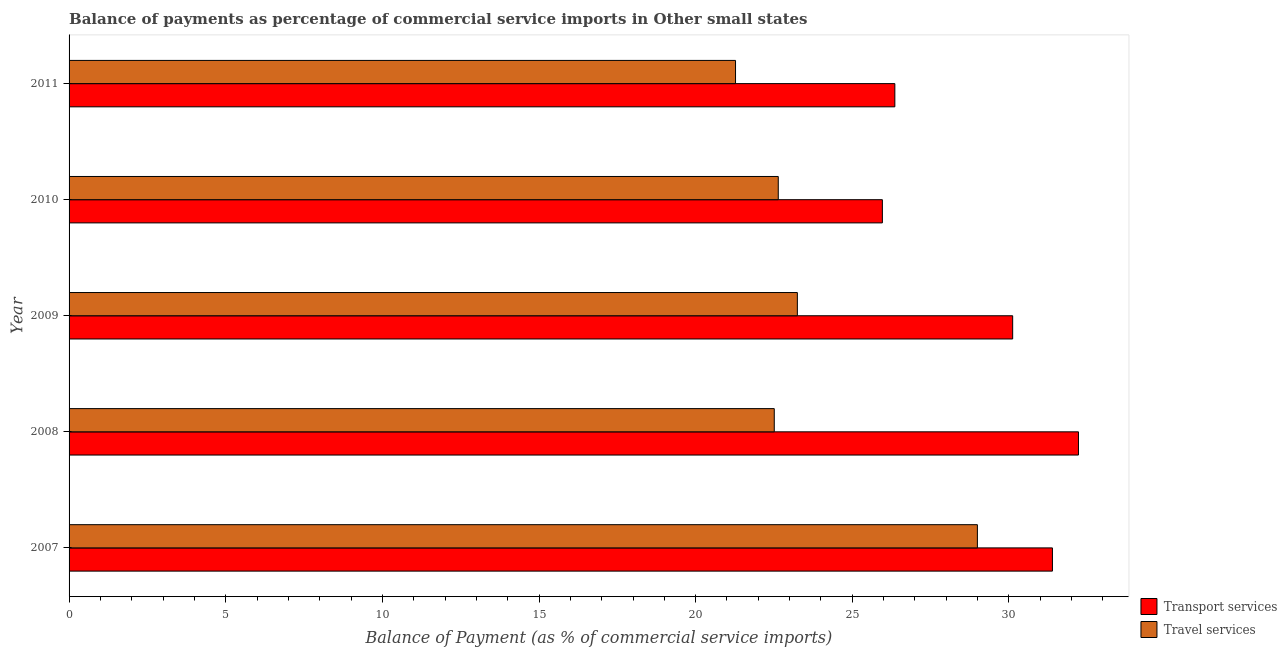How many different coloured bars are there?
Your response must be concise. 2. Are the number of bars on each tick of the Y-axis equal?
Ensure brevity in your answer.  Yes. How many bars are there on the 1st tick from the top?
Offer a terse response. 2. How many bars are there on the 5th tick from the bottom?
Offer a very short reply. 2. What is the balance of payments of travel services in 2008?
Provide a short and direct response. 22.51. Across all years, what is the maximum balance of payments of travel services?
Provide a short and direct response. 28.99. Across all years, what is the minimum balance of payments of transport services?
Keep it short and to the point. 25.96. In which year was the balance of payments of transport services minimum?
Your answer should be compact. 2010. What is the total balance of payments of travel services in the graph?
Offer a terse response. 118.66. What is the difference between the balance of payments of transport services in 2007 and that in 2010?
Offer a very short reply. 5.43. What is the difference between the balance of payments of transport services in 2011 and the balance of payments of travel services in 2010?
Provide a succinct answer. 3.72. What is the average balance of payments of travel services per year?
Keep it short and to the point. 23.73. In the year 2008, what is the difference between the balance of payments of transport services and balance of payments of travel services?
Your answer should be very brief. 9.71. In how many years, is the balance of payments of travel services greater than 9 %?
Keep it short and to the point. 5. What is the ratio of the balance of payments of transport services in 2008 to that in 2009?
Make the answer very short. 1.07. Is the balance of payments of transport services in 2007 less than that in 2010?
Provide a succinct answer. No. What is the difference between the highest and the second highest balance of payments of travel services?
Give a very brief answer. 5.75. What is the difference between the highest and the lowest balance of payments of travel services?
Offer a terse response. 7.72. In how many years, is the balance of payments of transport services greater than the average balance of payments of transport services taken over all years?
Offer a terse response. 3. What does the 1st bar from the top in 2008 represents?
Make the answer very short. Travel services. What does the 2nd bar from the bottom in 2011 represents?
Your answer should be very brief. Travel services. How many years are there in the graph?
Your answer should be very brief. 5. Are the values on the major ticks of X-axis written in scientific E-notation?
Offer a terse response. No. Does the graph contain any zero values?
Offer a terse response. No. How many legend labels are there?
Offer a terse response. 2. How are the legend labels stacked?
Your answer should be very brief. Vertical. What is the title of the graph?
Your response must be concise. Balance of payments as percentage of commercial service imports in Other small states. What is the label or title of the X-axis?
Make the answer very short. Balance of Payment (as % of commercial service imports). What is the label or title of the Y-axis?
Provide a short and direct response. Year. What is the Balance of Payment (as % of commercial service imports) in Transport services in 2007?
Offer a terse response. 31.39. What is the Balance of Payment (as % of commercial service imports) in Travel services in 2007?
Provide a short and direct response. 28.99. What is the Balance of Payment (as % of commercial service imports) in Transport services in 2008?
Ensure brevity in your answer.  32.22. What is the Balance of Payment (as % of commercial service imports) in Travel services in 2008?
Ensure brevity in your answer.  22.51. What is the Balance of Payment (as % of commercial service imports) of Transport services in 2009?
Ensure brevity in your answer.  30.12. What is the Balance of Payment (as % of commercial service imports) in Travel services in 2009?
Your answer should be compact. 23.25. What is the Balance of Payment (as % of commercial service imports) in Transport services in 2010?
Keep it short and to the point. 25.96. What is the Balance of Payment (as % of commercial service imports) of Travel services in 2010?
Provide a succinct answer. 22.64. What is the Balance of Payment (as % of commercial service imports) in Transport services in 2011?
Offer a very short reply. 26.36. What is the Balance of Payment (as % of commercial service imports) in Travel services in 2011?
Your answer should be very brief. 21.27. Across all years, what is the maximum Balance of Payment (as % of commercial service imports) of Transport services?
Offer a terse response. 32.22. Across all years, what is the maximum Balance of Payment (as % of commercial service imports) in Travel services?
Offer a very short reply. 28.99. Across all years, what is the minimum Balance of Payment (as % of commercial service imports) of Transport services?
Offer a terse response. 25.96. Across all years, what is the minimum Balance of Payment (as % of commercial service imports) of Travel services?
Keep it short and to the point. 21.27. What is the total Balance of Payment (as % of commercial service imports) of Transport services in the graph?
Make the answer very short. 146.05. What is the total Balance of Payment (as % of commercial service imports) in Travel services in the graph?
Provide a succinct answer. 118.66. What is the difference between the Balance of Payment (as % of commercial service imports) of Transport services in 2007 and that in 2008?
Provide a succinct answer. -0.83. What is the difference between the Balance of Payment (as % of commercial service imports) in Travel services in 2007 and that in 2008?
Your answer should be compact. 6.48. What is the difference between the Balance of Payment (as % of commercial service imports) in Transport services in 2007 and that in 2009?
Your response must be concise. 1.27. What is the difference between the Balance of Payment (as % of commercial service imports) of Travel services in 2007 and that in 2009?
Keep it short and to the point. 5.75. What is the difference between the Balance of Payment (as % of commercial service imports) of Transport services in 2007 and that in 2010?
Your answer should be compact. 5.43. What is the difference between the Balance of Payment (as % of commercial service imports) of Travel services in 2007 and that in 2010?
Your response must be concise. 6.36. What is the difference between the Balance of Payment (as % of commercial service imports) in Transport services in 2007 and that in 2011?
Ensure brevity in your answer.  5.03. What is the difference between the Balance of Payment (as % of commercial service imports) of Travel services in 2007 and that in 2011?
Keep it short and to the point. 7.72. What is the difference between the Balance of Payment (as % of commercial service imports) of Transport services in 2008 and that in 2009?
Your answer should be compact. 2.1. What is the difference between the Balance of Payment (as % of commercial service imports) of Travel services in 2008 and that in 2009?
Provide a short and direct response. -0.74. What is the difference between the Balance of Payment (as % of commercial service imports) in Transport services in 2008 and that in 2010?
Offer a terse response. 6.26. What is the difference between the Balance of Payment (as % of commercial service imports) of Travel services in 2008 and that in 2010?
Offer a terse response. -0.13. What is the difference between the Balance of Payment (as % of commercial service imports) of Transport services in 2008 and that in 2011?
Keep it short and to the point. 5.86. What is the difference between the Balance of Payment (as % of commercial service imports) of Travel services in 2008 and that in 2011?
Make the answer very short. 1.24. What is the difference between the Balance of Payment (as % of commercial service imports) in Transport services in 2009 and that in 2010?
Offer a terse response. 4.16. What is the difference between the Balance of Payment (as % of commercial service imports) in Travel services in 2009 and that in 2010?
Provide a short and direct response. 0.61. What is the difference between the Balance of Payment (as % of commercial service imports) in Transport services in 2009 and that in 2011?
Your answer should be compact. 3.76. What is the difference between the Balance of Payment (as % of commercial service imports) of Travel services in 2009 and that in 2011?
Give a very brief answer. 1.97. What is the difference between the Balance of Payment (as % of commercial service imports) of Transport services in 2010 and that in 2011?
Offer a very short reply. -0.4. What is the difference between the Balance of Payment (as % of commercial service imports) of Travel services in 2010 and that in 2011?
Your answer should be compact. 1.36. What is the difference between the Balance of Payment (as % of commercial service imports) in Transport services in 2007 and the Balance of Payment (as % of commercial service imports) in Travel services in 2008?
Provide a succinct answer. 8.88. What is the difference between the Balance of Payment (as % of commercial service imports) of Transport services in 2007 and the Balance of Payment (as % of commercial service imports) of Travel services in 2009?
Your response must be concise. 8.14. What is the difference between the Balance of Payment (as % of commercial service imports) in Transport services in 2007 and the Balance of Payment (as % of commercial service imports) in Travel services in 2010?
Offer a terse response. 8.75. What is the difference between the Balance of Payment (as % of commercial service imports) in Transport services in 2007 and the Balance of Payment (as % of commercial service imports) in Travel services in 2011?
Offer a terse response. 10.12. What is the difference between the Balance of Payment (as % of commercial service imports) in Transport services in 2008 and the Balance of Payment (as % of commercial service imports) in Travel services in 2009?
Offer a very short reply. 8.97. What is the difference between the Balance of Payment (as % of commercial service imports) in Transport services in 2008 and the Balance of Payment (as % of commercial service imports) in Travel services in 2010?
Ensure brevity in your answer.  9.58. What is the difference between the Balance of Payment (as % of commercial service imports) in Transport services in 2008 and the Balance of Payment (as % of commercial service imports) in Travel services in 2011?
Keep it short and to the point. 10.95. What is the difference between the Balance of Payment (as % of commercial service imports) of Transport services in 2009 and the Balance of Payment (as % of commercial service imports) of Travel services in 2010?
Your response must be concise. 7.48. What is the difference between the Balance of Payment (as % of commercial service imports) in Transport services in 2009 and the Balance of Payment (as % of commercial service imports) in Travel services in 2011?
Ensure brevity in your answer.  8.85. What is the difference between the Balance of Payment (as % of commercial service imports) in Transport services in 2010 and the Balance of Payment (as % of commercial service imports) in Travel services in 2011?
Your answer should be very brief. 4.69. What is the average Balance of Payment (as % of commercial service imports) in Transport services per year?
Provide a succinct answer. 29.21. What is the average Balance of Payment (as % of commercial service imports) of Travel services per year?
Provide a succinct answer. 23.73. In the year 2007, what is the difference between the Balance of Payment (as % of commercial service imports) in Transport services and Balance of Payment (as % of commercial service imports) in Travel services?
Provide a succinct answer. 2.4. In the year 2008, what is the difference between the Balance of Payment (as % of commercial service imports) of Transport services and Balance of Payment (as % of commercial service imports) of Travel services?
Provide a short and direct response. 9.71. In the year 2009, what is the difference between the Balance of Payment (as % of commercial service imports) of Transport services and Balance of Payment (as % of commercial service imports) of Travel services?
Your answer should be compact. 6.87. In the year 2010, what is the difference between the Balance of Payment (as % of commercial service imports) of Transport services and Balance of Payment (as % of commercial service imports) of Travel services?
Offer a very short reply. 3.32. In the year 2011, what is the difference between the Balance of Payment (as % of commercial service imports) of Transport services and Balance of Payment (as % of commercial service imports) of Travel services?
Provide a short and direct response. 5.09. What is the ratio of the Balance of Payment (as % of commercial service imports) of Transport services in 2007 to that in 2008?
Give a very brief answer. 0.97. What is the ratio of the Balance of Payment (as % of commercial service imports) in Travel services in 2007 to that in 2008?
Your response must be concise. 1.29. What is the ratio of the Balance of Payment (as % of commercial service imports) in Transport services in 2007 to that in 2009?
Offer a terse response. 1.04. What is the ratio of the Balance of Payment (as % of commercial service imports) in Travel services in 2007 to that in 2009?
Ensure brevity in your answer.  1.25. What is the ratio of the Balance of Payment (as % of commercial service imports) of Transport services in 2007 to that in 2010?
Your answer should be very brief. 1.21. What is the ratio of the Balance of Payment (as % of commercial service imports) of Travel services in 2007 to that in 2010?
Your answer should be very brief. 1.28. What is the ratio of the Balance of Payment (as % of commercial service imports) in Transport services in 2007 to that in 2011?
Provide a succinct answer. 1.19. What is the ratio of the Balance of Payment (as % of commercial service imports) of Travel services in 2007 to that in 2011?
Your answer should be compact. 1.36. What is the ratio of the Balance of Payment (as % of commercial service imports) in Transport services in 2008 to that in 2009?
Your response must be concise. 1.07. What is the ratio of the Balance of Payment (as % of commercial service imports) in Travel services in 2008 to that in 2009?
Keep it short and to the point. 0.97. What is the ratio of the Balance of Payment (as % of commercial service imports) of Transport services in 2008 to that in 2010?
Offer a terse response. 1.24. What is the ratio of the Balance of Payment (as % of commercial service imports) in Travel services in 2008 to that in 2010?
Give a very brief answer. 0.99. What is the ratio of the Balance of Payment (as % of commercial service imports) in Transport services in 2008 to that in 2011?
Keep it short and to the point. 1.22. What is the ratio of the Balance of Payment (as % of commercial service imports) in Travel services in 2008 to that in 2011?
Offer a very short reply. 1.06. What is the ratio of the Balance of Payment (as % of commercial service imports) of Transport services in 2009 to that in 2010?
Keep it short and to the point. 1.16. What is the ratio of the Balance of Payment (as % of commercial service imports) of Travel services in 2009 to that in 2010?
Offer a very short reply. 1.03. What is the ratio of the Balance of Payment (as % of commercial service imports) of Transport services in 2009 to that in 2011?
Give a very brief answer. 1.14. What is the ratio of the Balance of Payment (as % of commercial service imports) in Travel services in 2009 to that in 2011?
Keep it short and to the point. 1.09. What is the ratio of the Balance of Payment (as % of commercial service imports) of Transport services in 2010 to that in 2011?
Offer a terse response. 0.98. What is the ratio of the Balance of Payment (as % of commercial service imports) of Travel services in 2010 to that in 2011?
Keep it short and to the point. 1.06. What is the difference between the highest and the second highest Balance of Payment (as % of commercial service imports) of Transport services?
Your answer should be compact. 0.83. What is the difference between the highest and the second highest Balance of Payment (as % of commercial service imports) of Travel services?
Provide a short and direct response. 5.75. What is the difference between the highest and the lowest Balance of Payment (as % of commercial service imports) in Transport services?
Offer a terse response. 6.26. What is the difference between the highest and the lowest Balance of Payment (as % of commercial service imports) of Travel services?
Ensure brevity in your answer.  7.72. 